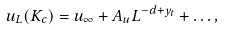<formula> <loc_0><loc_0><loc_500><loc_500>u _ { L } ( K _ { c } ) = u _ { \infty } + A _ { u } L ^ { - d + y _ { t } } + \dots ,</formula> 